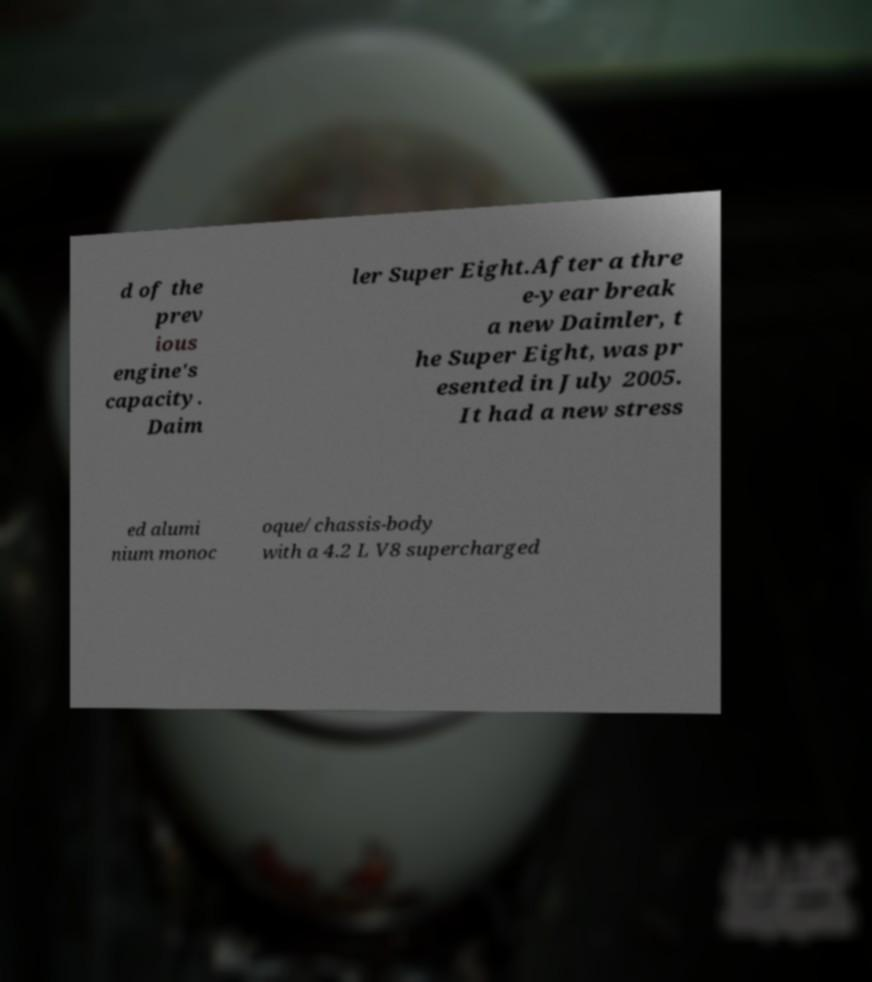Could you assist in decoding the text presented in this image and type it out clearly? d of the prev ious engine's capacity. Daim ler Super Eight.After a thre e-year break a new Daimler, t he Super Eight, was pr esented in July 2005. It had a new stress ed alumi nium monoc oque/chassis-body with a 4.2 L V8 supercharged 